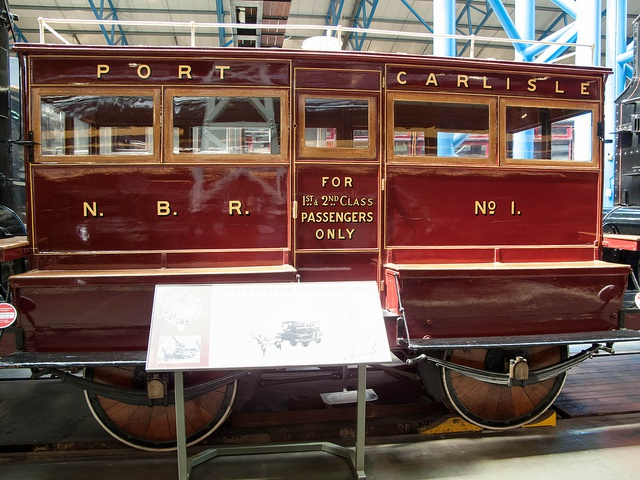Describe the objects in this image and their specific colors. I can see a train in black, maroon, gray, and white tones in this image. 